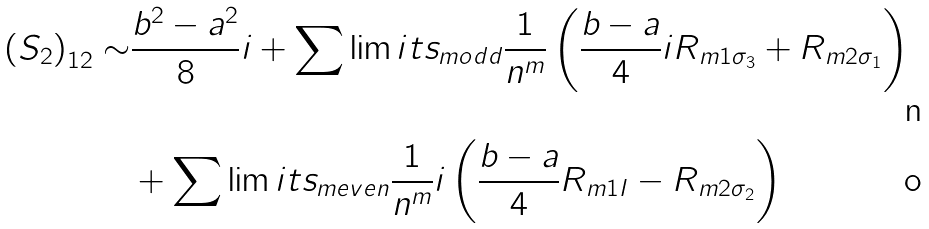Convert formula to latex. <formula><loc_0><loc_0><loc_500><loc_500>\left ( S _ { 2 } \right ) _ { 1 2 } \sim & \frac { b ^ { 2 } - a ^ { 2 } } { 8 } i + \sum \lim i t s _ { m o d d } \frac { 1 } { n ^ { m } } \left ( \frac { b - a } { 4 } i R _ { m 1 \sigma _ { 3 } } + R _ { m 2 \sigma _ { 1 } } \right ) \\ & + \sum \lim i t s _ { m e v e n } \frac { 1 } { n ^ { m } } i \left ( \frac { b - a } { 4 } R _ { m 1 I } - R _ { m 2 \sigma _ { 2 } } \right )</formula> 